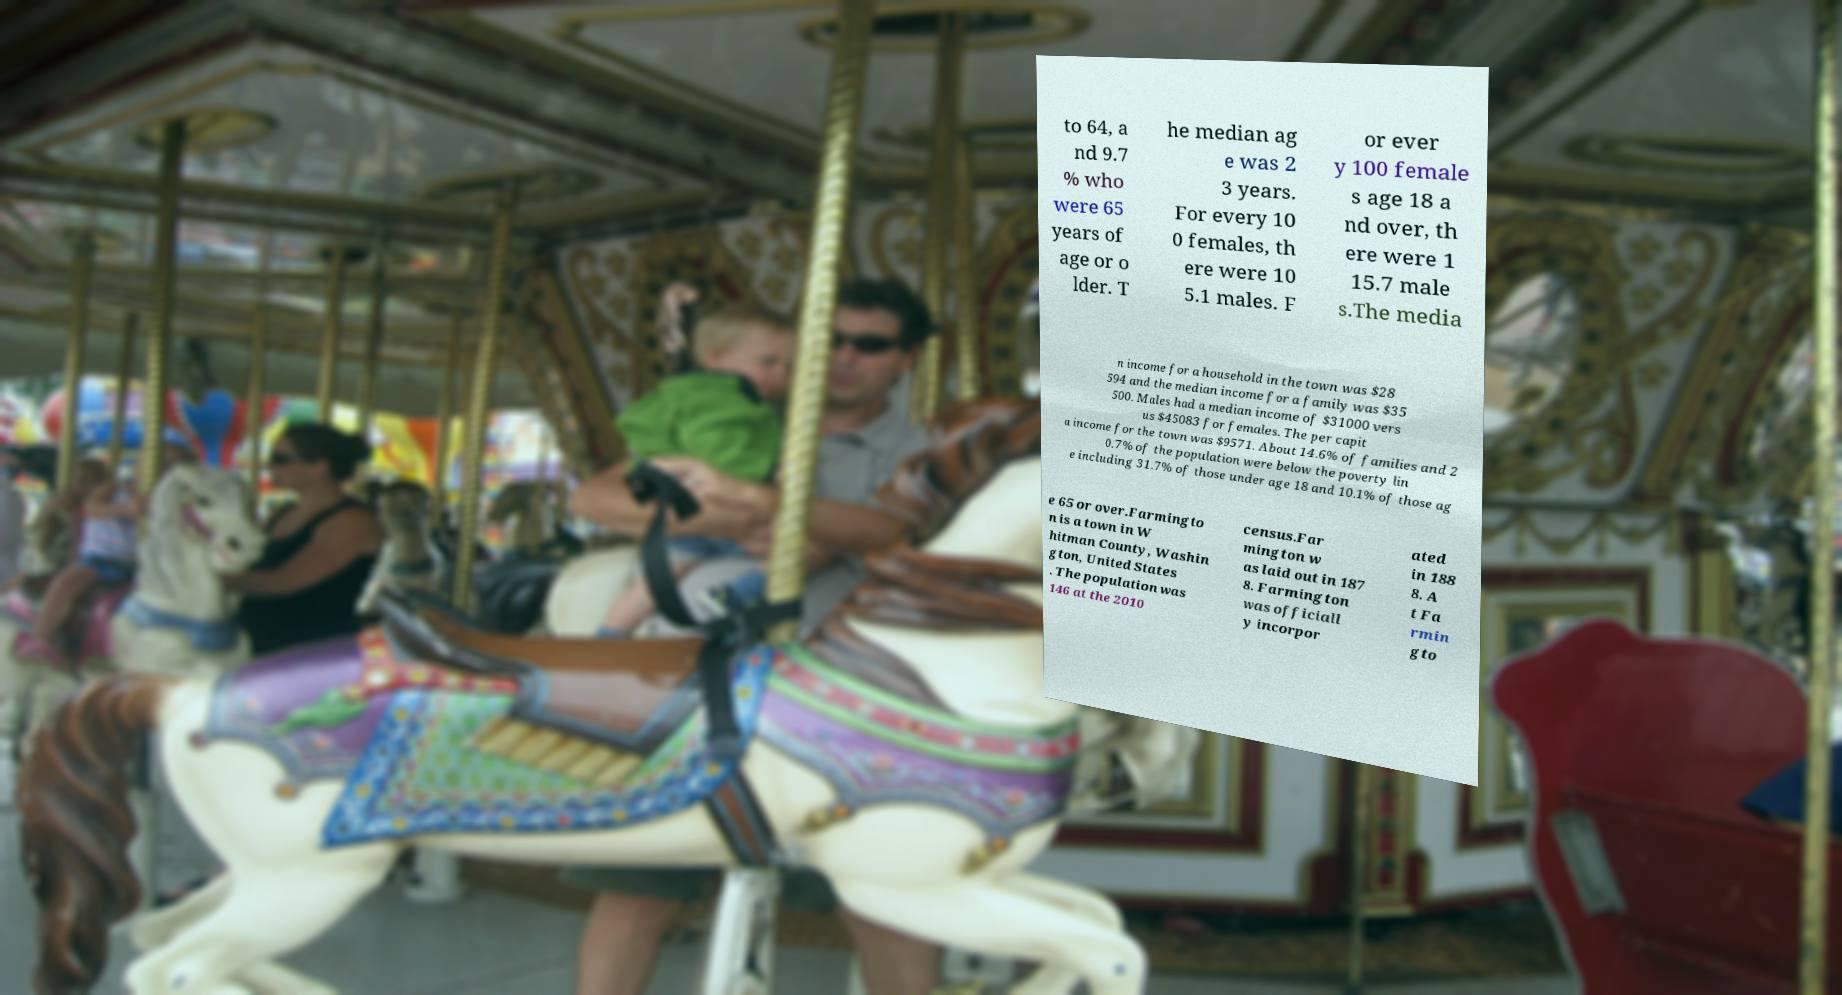There's text embedded in this image that I need extracted. Can you transcribe it verbatim? to 64, a nd 9.7 % who were 65 years of age or o lder. T he median ag e was 2 3 years. For every 10 0 females, th ere were 10 5.1 males. F or ever y 100 female s age 18 a nd over, th ere were 1 15.7 male s.The media n income for a household in the town was $28 594 and the median income for a family was $35 500. Males had a median income of $31000 vers us $45083 for females. The per capit a income for the town was $9571. About 14.6% of families and 2 0.7% of the population were below the poverty lin e including 31.7% of those under age 18 and 10.1% of those ag e 65 or over.Farmingto n is a town in W hitman County, Washin gton, United States . The population was 146 at the 2010 census.Far mington w as laid out in 187 8. Farmington was officiall y incorpor ated in 188 8. A t Fa rmin gto 